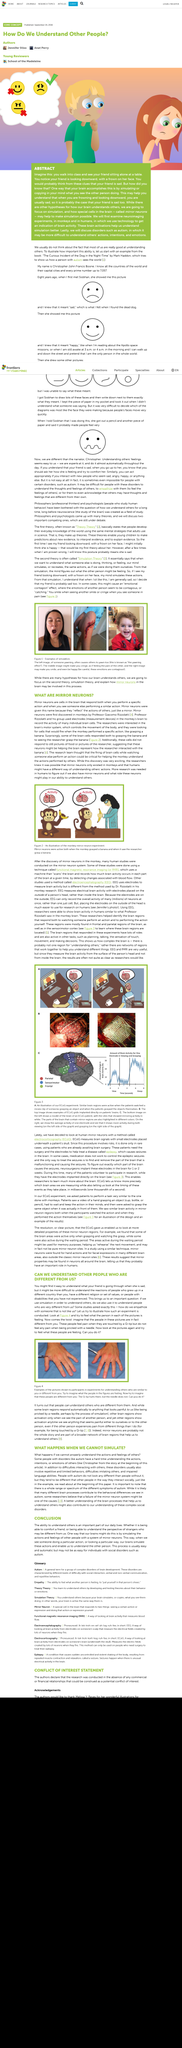Give some essential details in this illustration. The process of understanding others is usually easy and automatic. The ability to understand others is a crucial aspect of our daily lives, as stated in the conclusion of the text. The simulation of actions by the brain when observing others enables understanding of their actions. 